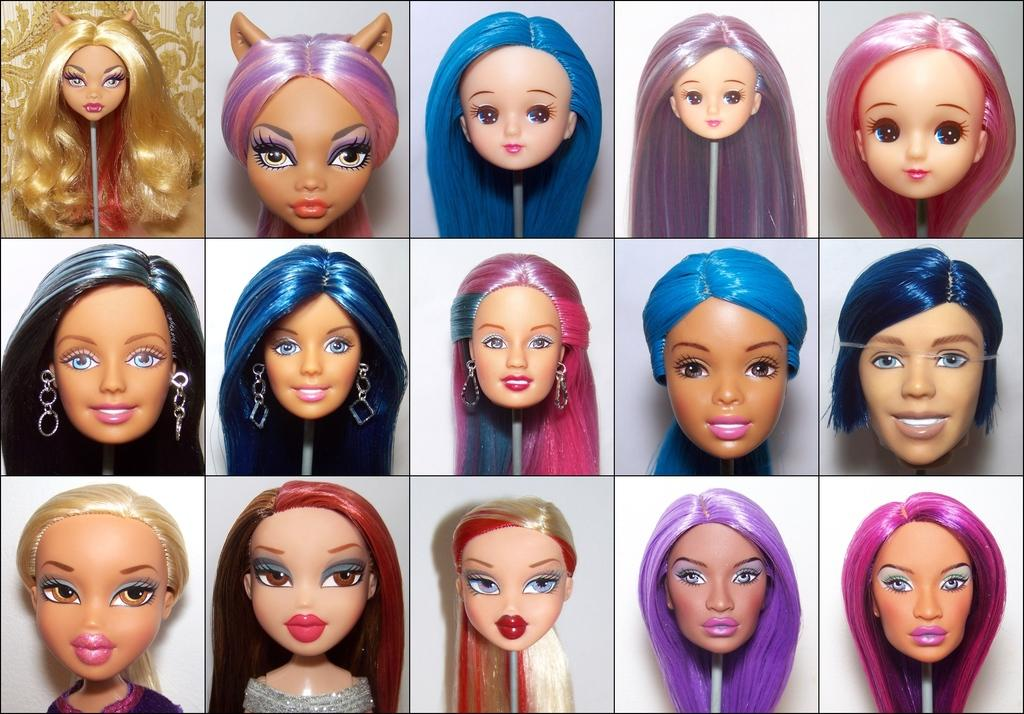What type of artwork is depicted in the image? The image is a collage. What is the main subject of the collage? The collage consists of doll faces. How many umbrellas are used to create the collage? There are no umbrellas present in the collage; it consists of doll faces. What type of animal can be seen interacting with the doll faces in the image? There are no animals present in the image; it consists of doll faces. 